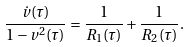<formula> <loc_0><loc_0><loc_500><loc_500>\frac { \dot { v } ( \tau ) } { 1 - v ^ { 2 } ( \tau ) } = \frac { 1 } { R _ { 1 } ( \tau ) } + \frac { 1 } { R _ { 2 } ( \tau ) } .</formula> 